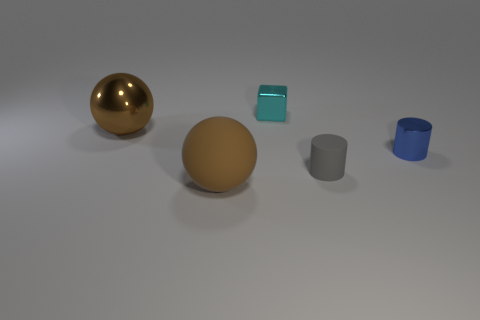What color is the metallic object that is in front of the shiny cube and on the right side of the large brown matte sphere?
Offer a very short reply. Blue. Do the small blue cylinder and the tiny gray object have the same material?
Give a very brief answer. No. The tiny cyan metallic thing is what shape?
Keep it short and to the point. Cube. There is a object that is behind the metallic thing left of the cyan thing; what number of large spheres are in front of it?
Provide a succinct answer. 2. There is another tiny shiny thing that is the same shape as the small gray thing; what color is it?
Provide a succinct answer. Blue. The tiny object that is behind the big brown ball behind the large brown ball that is in front of the tiny gray thing is what shape?
Your answer should be very brief. Cube. There is a metallic object that is to the right of the big shiny ball and in front of the tiny shiny block; how big is it?
Your answer should be compact. Small. Is the number of blue shiny cylinders less than the number of red cubes?
Make the answer very short. No. There is a brown sphere that is in front of the shiny cylinder; how big is it?
Make the answer very short. Large. There is a object that is both on the left side of the small metallic cube and in front of the large metal thing; what is its shape?
Make the answer very short. Sphere. 